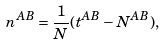<formula> <loc_0><loc_0><loc_500><loc_500>n ^ { A B } = \frac { 1 } { N } ( t ^ { A B } - N ^ { A B } ) ,</formula> 